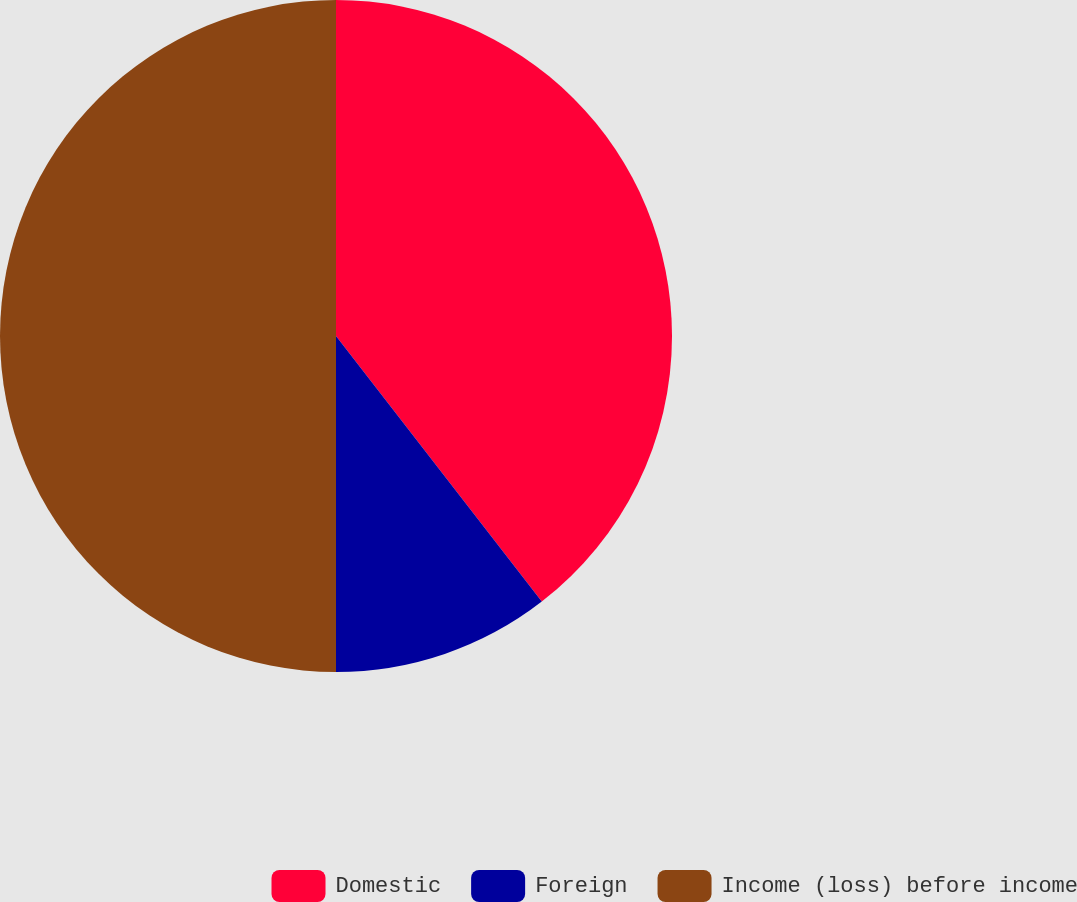Convert chart to OTSL. <chart><loc_0><loc_0><loc_500><loc_500><pie_chart><fcel>Domestic<fcel>Foreign<fcel>Income (loss) before income<nl><fcel>39.51%<fcel>10.49%<fcel>50.0%<nl></chart> 